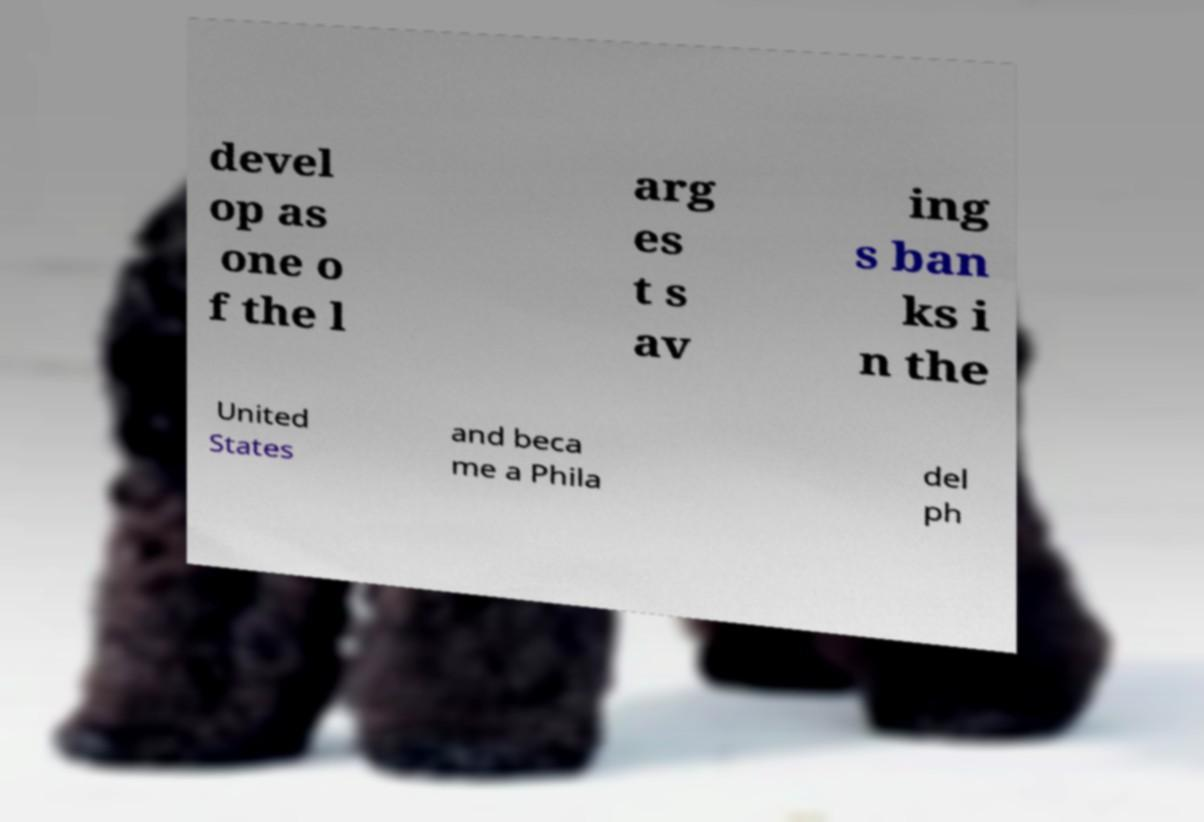Please read and relay the text visible in this image. What does it say? devel op as one o f the l arg es t s av ing s ban ks i n the United States and beca me a Phila del ph 